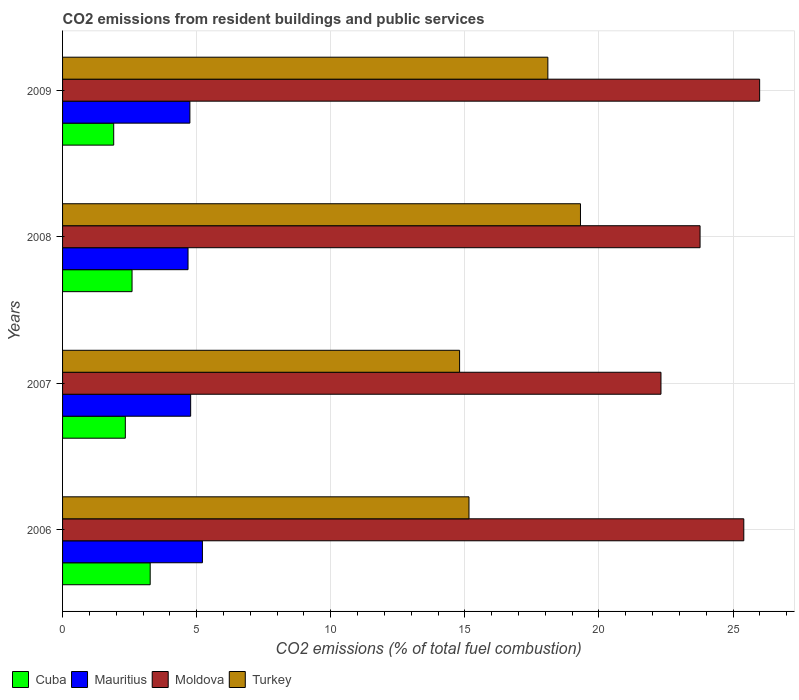How many different coloured bars are there?
Provide a succinct answer. 4. Are the number of bars per tick equal to the number of legend labels?
Your response must be concise. Yes. Are the number of bars on each tick of the Y-axis equal?
Provide a short and direct response. Yes. What is the label of the 3rd group of bars from the top?
Give a very brief answer. 2007. What is the total CO2 emitted in Turkey in 2006?
Offer a very short reply. 15.15. Across all years, what is the maximum total CO2 emitted in Moldova?
Make the answer very short. 25.99. Across all years, what is the minimum total CO2 emitted in Moldova?
Give a very brief answer. 22.31. What is the total total CO2 emitted in Turkey in the graph?
Offer a very short reply. 67.36. What is the difference between the total CO2 emitted in Mauritius in 2006 and that in 2008?
Give a very brief answer. 0.54. What is the difference between the total CO2 emitted in Cuba in 2009 and the total CO2 emitted in Turkey in 2008?
Provide a succinct answer. -17.4. What is the average total CO2 emitted in Moldova per year?
Provide a succinct answer. 24.37. In the year 2008, what is the difference between the total CO2 emitted in Moldova and total CO2 emitted in Mauritius?
Give a very brief answer. 19.09. What is the ratio of the total CO2 emitted in Cuba in 2007 to that in 2009?
Provide a succinct answer. 1.23. What is the difference between the highest and the second highest total CO2 emitted in Mauritius?
Offer a very short reply. 0.44. What is the difference between the highest and the lowest total CO2 emitted in Cuba?
Give a very brief answer. 1.36. In how many years, is the total CO2 emitted in Moldova greater than the average total CO2 emitted in Moldova taken over all years?
Offer a terse response. 2. Is the sum of the total CO2 emitted in Cuba in 2008 and 2009 greater than the maximum total CO2 emitted in Turkey across all years?
Your response must be concise. No. What does the 4th bar from the top in 2007 represents?
Make the answer very short. Cuba. How many bars are there?
Your answer should be very brief. 16. Are all the bars in the graph horizontal?
Your answer should be very brief. Yes. How many years are there in the graph?
Ensure brevity in your answer.  4. Does the graph contain any zero values?
Ensure brevity in your answer.  No. Does the graph contain grids?
Your answer should be compact. Yes. Where does the legend appear in the graph?
Your response must be concise. Bottom left. How many legend labels are there?
Make the answer very short. 4. What is the title of the graph?
Give a very brief answer. CO2 emissions from resident buildings and public services. What is the label or title of the X-axis?
Offer a very short reply. CO2 emissions (% of total fuel combustion). What is the CO2 emissions (% of total fuel combustion) in Cuba in 2006?
Offer a terse response. 3.27. What is the CO2 emissions (% of total fuel combustion) of Mauritius in 2006?
Keep it short and to the point. 5.21. What is the CO2 emissions (% of total fuel combustion) in Moldova in 2006?
Provide a succinct answer. 25.4. What is the CO2 emissions (% of total fuel combustion) of Turkey in 2006?
Keep it short and to the point. 15.15. What is the CO2 emissions (% of total fuel combustion) of Cuba in 2007?
Offer a very short reply. 2.34. What is the CO2 emissions (% of total fuel combustion) in Mauritius in 2007?
Your response must be concise. 4.78. What is the CO2 emissions (% of total fuel combustion) in Moldova in 2007?
Offer a very short reply. 22.31. What is the CO2 emissions (% of total fuel combustion) in Turkey in 2007?
Provide a short and direct response. 14.8. What is the CO2 emissions (% of total fuel combustion) of Cuba in 2008?
Give a very brief answer. 2.59. What is the CO2 emissions (% of total fuel combustion) of Mauritius in 2008?
Keep it short and to the point. 4.68. What is the CO2 emissions (% of total fuel combustion) of Moldova in 2008?
Offer a terse response. 23.77. What is the CO2 emissions (% of total fuel combustion) in Turkey in 2008?
Make the answer very short. 19.31. What is the CO2 emissions (% of total fuel combustion) of Cuba in 2009?
Offer a terse response. 1.91. What is the CO2 emissions (% of total fuel combustion) in Mauritius in 2009?
Give a very brief answer. 4.75. What is the CO2 emissions (% of total fuel combustion) of Moldova in 2009?
Offer a terse response. 25.99. What is the CO2 emissions (% of total fuel combustion) in Turkey in 2009?
Offer a terse response. 18.1. Across all years, what is the maximum CO2 emissions (% of total fuel combustion) in Cuba?
Your answer should be very brief. 3.27. Across all years, what is the maximum CO2 emissions (% of total fuel combustion) in Mauritius?
Provide a short and direct response. 5.21. Across all years, what is the maximum CO2 emissions (% of total fuel combustion) in Moldova?
Provide a short and direct response. 25.99. Across all years, what is the maximum CO2 emissions (% of total fuel combustion) in Turkey?
Ensure brevity in your answer.  19.31. Across all years, what is the minimum CO2 emissions (% of total fuel combustion) of Cuba?
Offer a terse response. 1.91. Across all years, what is the minimum CO2 emissions (% of total fuel combustion) of Mauritius?
Offer a terse response. 4.68. Across all years, what is the minimum CO2 emissions (% of total fuel combustion) in Moldova?
Your answer should be compact. 22.31. Across all years, what is the minimum CO2 emissions (% of total fuel combustion) of Turkey?
Offer a very short reply. 14.8. What is the total CO2 emissions (% of total fuel combustion) in Cuba in the graph?
Ensure brevity in your answer.  10.1. What is the total CO2 emissions (% of total fuel combustion) of Mauritius in the graph?
Keep it short and to the point. 19.42. What is the total CO2 emissions (% of total fuel combustion) of Moldova in the graph?
Ensure brevity in your answer.  97.48. What is the total CO2 emissions (% of total fuel combustion) of Turkey in the graph?
Offer a terse response. 67.36. What is the difference between the CO2 emissions (% of total fuel combustion) in Cuba in 2006 and that in 2007?
Offer a very short reply. 0.93. What is the difference between the CO2 emissions (% of total fuel combustion) of Mauritius in 2006 and that in 2007?
Give a very brief answer. 0.44. What is the difference between the CO2 emissions (% of total fuel combustion) of Moldova in 2006 and that in 2007?
Provide a short and direct response. 3.09. What is the difference between the CO2 emissions (% of total fuel combustion) in Turkey in 2006 and that in 2007?
Provide a succinct answer. 0.35. What is the difference between the CO2 emissions (% of total fuel combustion) in Cuba in 2006 and that in 2008?
Keep it short and to the point. 0.68. What is the difference between the CO2 emissions (% of total fuel combustion) of Mauritius in 2006 and that in 2008?
Provide a short and direct response. 0.54. What is the difference between the CO2 emissions (% of total fuel combustion) of Moldova in 2006 and that in 2008?
Your answer should be compact. 1.63. What is the difference between the CO2 emissions (% of total fuel combustion) of Turkey in 2006 and that in 2008?
Offer a terse response. -4.16. What is the difference between the CO2 emissions (% of total fuel combustion) in Cuba in 2006 and that in 2009?
Your response must be concise. 1.36. What is the difference between the CO2 emissions (% of total fuel combustion) in Mauritius in 2006 and that in 2009?
Ensure brevity in your answer.  0.47. What is the difference between the CO2 emissions (% of total fuel combustion) of Moldova in 2006 and that in 2009?
Provide a short and direct response. -0.59. What is the difference between the CO2 emissions (% of total fuel combustion) in Turkey in 2006 and that in 2009?
Your answer should be compact. -2.94. What is the difference between the CO2 emissions (% of total fuel combustion) of Cuba in 2007 and that in 2008?
Ensure brevity in your answer.  -0.25. What is the difference between the CO2 emissions (% of total fuel combustion) in Mauritius in 2007 and that in 2008?
Your answer should be very brief. 0.1. What is the difference between the CO2 emissions (% of total fuel combustion) of Moldova in 2007 and that in 2008?
Offer a terse response. -1.46. What is the difference between the CO2 emissions (% of total fuel combustion) of Turkey in 2007 and that in 2008?
Your answer should be very brief. -4.51. What is the difference between the CO2 emissions (% of total fuel combustion) of Cuba in 2007 and that in 2009?
Your answer should be compact. 0.43. What is the difference between the CO2 emissions (% of total fuel combustion) in Mauritius in 2007 and that in 2009?
Offer a very short reply. 0.03. What is the difference between the CO2 emissions (% of total fuel combustion) of Moldova in 2007 and that in 2009?
Offer a very short reply. -3.68. What is the difference between the CO2 emissions (% of total fuel combustion) in Turkey in 2007 and that in 2009?
Your response must be concise. -3.29. What is the difference between the CO2 emissions (% of total fuel combustion) of Cuba in 2008 and that in 2009?
Provide a short and direct response. 0.68. What is the difference between the CO2 emissions (% of total fuel combustion) of Mauritius in 2008 and that in 2009?
Keep it short and to the point. -0.07. What is the difference between the CO2 emissions (% of total fuel combustion) in Moldova in 2008 and that in 2009?
Keep it short and to the point. -2.22. What is the difference between the CO2 emissions (% of total fuel combustion) in Turkey in 2008 and that in 2009?
Your answer should be very brief. 1.22. What is the difference between the CO2 emissions (% of total fuel combustion) in Cuba in 2006 and the CO2 emissions (% of total fuel combustion) in Mauritius in 2007?
Your answer should be compact. -1.51. What is the difference between the CO2 emissions (% of total fuel combustion) in Cuba in 2006 and the CO2 emissions (% of total fuel combustion) in Moldova in 2007?
Offer a very short reply. -19.05. What is the difference between the CO2 emissions (% of total fuel combustion) of Cuba in 2006 and the CO2 emissions (% of total fuel combustion) of Turkey in 2007?
Give a very brief answer. -11.54. What is the difference between the CO2 emissions (% of total fuel combustion) in Mauritius in 2006 and the CO2 emissions (% of total fuel combustion) in Moldova in 2007?
Offer a terse response. -17.1. What is the difference between the CO2 emissions (% of total fuel combustion) in Mauritius in 2006 and the CO2 emissions (% of total fuel combustion) in Turkey in 2007?
Offer a terse response. -9.59. What is the difference between the CO2 emissions (% of total fuel combustion) of Moldova in 2006 and the CO2 emissions (% of total fuel combustion) of Turkey in 2007?
Make the answer very short. 10.6. What is the difference between the CO2 emissions (% of total fuel combustion) of Cuba in 2006 and the CO2 emissions (% of total fuel combustion) of Mauritius in 2008?
Offer a very short reply. -1.41. What is the difference between the CO2 emissions (% of total fuel combustion) in Cuba in 2006 and the CO2 emissions (% of total fuel combustion) in Moldova in 2008?
Provide a succinct answer. -20.5. What is the difference between the CO2 emissions (% of total fuel combustion) in Cuba in 2006 and the CO2 emissions (% of total fuel combustion) in Turkey in 2008?
Provide a succinct answer. -16.04. What is the difference between the CO2 emissions (% of total fuel combustion) of Mauritius in 2006 and the CO2 emissions (% of total fuel combustion) of Moldova in 2008?
Keep it short and to the point. -18.56. What is the difference between the CO2 emissions (% of total fuel combustion) in Mauritius in 2006 and the CO2 emissions (% of total fuel combustion) in Turkey in 2008?
Your answer should be compact. -14.1. What is the difference between the CO2 emissions (% of total fuel combustion) of Moldova in 2006 and the CO2 emissions (% of total fuel combustion) of Turkey in 2008?
Provide a short and direct response. 6.09. What is the difference between the CO2 emissions (% of total fuel combustion) of Cuba in 2006 and the CO2 emissions (% of total fuel combustion) of Mauritius in 2009?
Provide a short and direct response. -1.48. What is the difference between the CO2 emissions (% of total fuel combustion) in Cuba in 2006 and the CO2 emissions (% of total fuel combustion) in Moldova in 2009?
Ensure brevity in your answer.  -22.72. What is the difference between the CO2 emissions (% of total fuel combustion) of Cuba in 2006 and the CO2 emissions (% of total fuel combustion) of Turkey in 2009?
Offer a very short reply. -14.83. What is the difference between the CO2 emissions (% of total fuel combustion) of Mauritius in 2006 and the CO2 emissions (% of total fuel combustion) of Moldova in 2009?
Ensure brevity in your answer.  -20.78. What is the difference between the CO2 emissions (% of total fuel combustion) in Mauritius in 2006 and the CO2 emissions (% of total fuel combustion) in Turkey in 2009?
Your answer should be compact. -12.88. What is the difference between the CO2 emissions (% of total fuel combustion) of Moldova in 2006 and the CO2 emissions (% of total fuel combustion) of Turkey in 2009?
Your answer should be compact. 7.31. What is the difference between the CO2 emissions (% of total fuel combustion) in Cuba in 2007 and the CO2 emissions (% of total fuel combustion) in Mauritius in 2008?
Provide a succinct answer. -2.34. What is the difference between the CO2 emissions (% of total fuel combustion) of Cuba in 2007 and the CO2 emissions (% of total fuel combustion) of Moldova in 2008?
Make the answer very short. -21.43. What is the difference between the CO2 emissions (% of total fuel combustion) of Cuba in 2007 and the CO2 emissions (% of total fuel combustion) of Turkey in 2008?
Make the answer very short. -16.97. What is the difference between the CO2 emissions (% of total fuel combustion) of Mauritius in 2007 and the CO2 emissions (% of total fuel combustion) of Moldova in 2008?
Ensure brevity in your answer.  -18.99. What is the difference between the CO2 emissions (% of total fuel combustion) of Mauritius in 2007 and the CO2 emissions (% of total fuel combustion) of Turkey in 2008?
Your answer should be very brief. -14.53. What is the difference between the CO2 emissions (% of total fuel combustion) in Moldova in 2007 and the CO2 emissions (% of total fuel combustion) in Turkey in 2008?
Provide a short and direct response. 3. What is the difference between the CO2 emissions (% of total fuel combustion) in Cuba in 2007 and the CO2 emissions (% of total fuel combustion) in Mauritius in 2009?
Make the answer very short. -2.41. What is the difference between the CO2 emissions (% of total fuel combustion) in Cuba in 2007 and the CO2 emissions (% of total fuel combustion) in Moldova in 2009?
Make the answer very short. -23.65. What is the difference between the CO2 emissions (% of total fuel combustion) in Cuba in 2007 and the CO2 emissions (% of total fuel combustion) in Turkey in 2009?
Ensure brevity in your answer.  -15.75. What is the difference between the CO2 emissions (% of total fuel combustion) in Mauritius in 2007 and the CO2 emissions (% of total fuel combustion) in Moldova in 2009?
Provide a succinct answer. -21.22. What is the difference between the CO2 emissions (% of total fuel combustion) in Mauritius in 2007 and the CO2 emissions (% of total fuel combustion) in Turkey in 2009?
Provide a succinct answer. -13.32. What is the difference between the CO2 emissions (% of total fuel combustion) in Moldova in 2007 and the CO2 emissions (% of total fuel combustion) in Turkey in 2009?
Your answer should be very brief. 4.22. What is the difference between the CO2 emissions (% of total fuel combustion) in Cuba in 2008 and the CO2 emissions (% of total fuel combustion) in Mauritius in 2009?
Provide a short and direct response. -2.16. What is the difference between the CO2 emissions (% of total fuel combustion) of Cuba in 2008 and the CO2 emissions (% of total fuel combustion) of Moldova in 2009?
Offer a very short reply. -23.4. What is the difference between the CO2 emissions (% of total fuel combustion) of Cuba in 2008 and the CO2 emissions (% of total fuel combustion) of Turkey in 2009?
Make the answer very short. -15.5. What is the difference between the CO2 emissions (% of total fuel combustion) in Mauritius in 2008 and the CO2 emissions (% of total fuel combustion) in Moldova in 2009?
Make the answer very short. -21.31. What is the difference between the CO2 emissions (% of total fuel combustion) of Mauritius in 2008 and the CO2 emissions (% of total fuel combustion) of Turkey in 2009?
Make the answer very short. -13.42. What is the difference between the CO2 emissions (% of total fuel combustion) in Moldova in 2008 and the CO2 emissions (% of total fuel combustion) in Turkey in 2009?
Provide a short and direct response. 5.68. What is the average CO2 emissions (% of total fuel combustion) of Cuba per year?
Your answer should be very brief. 2.53. What is the average CO2 emissions (% of total fuel combustion) in Mauritius per year?
Your answer should be compact. 4.85. What is the average CO2 emissions (% of total fuel combustion) in Moldova per year?
Offer a terse response. 24.37. What is the average CO2 emissions (% of total fuel combustion) of Turkey per year?
Ensure brevity in your answer.  16.84. In the year 2006, what is the difference between the CO2 emissions (% of total fuel combustion) of Cuba and CO2 emissions (% of total fuel combustion) of Mauritius?
Provide a succinct answer. -1.95. In the year 2006, what is the difference between the CO2 emissions (% of total fuel combustion) in Cuba and CO2 emissions (% of total fuel combustion) in Moldova?
Offer a very short reply. -22.13. In the year 2006, what is the difference between the CO2 emissions (% of total fuel combustion) of Cuba and CO2 emissions (% of total fuel combustion) of Turkey?
Ensure brevity in your answer.  -11.89. In the year 2006, what is the difference between the CO2 emissions (% of total fuel combustion) of Mauritius and CO2 emissions (% of total fuel combustion) of Moldova?
Make the answer very short. -20.19. In the year 2006, what is the difference between the CO2 emissions (% of total fuel combustion) of Mauritius and CO2 emissions (% of total fuel combustion) of Turkey?
Keep it short and to the point. -9.94. In the year 2006, what is the difference between the CO2 emissions (% of total fuel combustion) in Moldova and CO2 emissions (% of total fuel combustion) in Turkey?
Offer a terse response. 10.25. In the year 2007, what is the difference between the CO2 emissions (% of total fuel combustion) of Cuba and CO2 emissions (% of total fuel combustion) of Mauritius?
Your response must be concise. -2.44. In the year 2007, what is the difference between the CO2 emissions (% of total fuel combustion) in Cuba and CO2 emissions (% of total fuel combustion) in Moldova?
Your response must be concise. -19.97. In the year 2007, what is the difference between the CO2 emissions (% of total fuel combustion) of Cuba and CO2 emissions (% of total fuel combustion) of Turkey?
Your answer should be very brief. -12.46. In the year 2007, what is the difference between the CO2 emissions (% of total fuel combustion) in Mauritius and CO2 emissions (% of total fuel combustion) in Moldova?
Your response must be concise. -17.54. In the year 2007, what is the difference between the CO2 emissions (% of total fuel combustion) of Mauritius and CO2 emissions (% of total fuel combustion) of Turkey?
Offer a terse response. -10.03. In the year 2007, what is the difference between the CO2 emissions (% of total fuel combustion) in Moldova and CO2 emissions (% of total fuel combustion) in Turkey?
Keep it short and to the point. 7.51. In the year 2008, what is the difference between the CO2 emissions (% of total fuel combustion) in Cuba and CO2 emissions (% of total fuel combustion) in Mauritius?
Provide a succinct answer. -2.09. In the year 2008, what is the difference between the CO2 emissions (% of total fuel combustion) of Cuba and CO2 emissions (% of total fuel combustion) of Moldova?
Offer a very short reply. -21.18. In the year 2008, what is the difference between the CO2 emissions (% of total fuel combustion) of Cuba and CO2 emissions (% of total fuel combustion) of Turkey?
Offer a terse response. -16.72. In the year 2008, what is the difference between the CO2 emissions (% of total fuel combustion) in Mauritius and CO2 emissions (% of total fuel combustion) in Moldova?
Your answer should be compact. -19.09. In the year 2008, what is the difference between the CO2 emissions (% of total fuel combustion) of Mauritius and CO2 emissions (% of total fuel combustion) of Turkey?
Make the answer very short. -14.63. In the year 2008, what is the difference between the CO2 emissions (% of total fuel combustion) of Moldova and CO2 emissions (% of total fuel combustion) of Turkey?
Ensure brevity in your answer.  4.46. In the year 2009, what is the difference between the CO2 emissions (% of total fuel combustion) of Cuba and CO2 emissions (% of total fuel combustion) of Mauritius?
Provide a succinct answer. -2.84. In the year 2009, what is the difference between the CO2 emissions (% of total fuel combustion) of Cuba and CO2 emissions (% of total fuel combustion) of Moldova?
Offer a terse response. -24.09. In the year 2009, what is the difference between the CO2 emissions (% of total fuel combustion) in Cuba and CO2 emissions (% of total fuel combustion) in Turkey?
Provide a succinct answer. -16.19. In the year 2009, what is the difference between the CO2 emissions (% of total fuel combustion) in Mauritius and CO2 emissions (% of total fuel combustion) in Moldova?
Provide a succinct answer. -21.24. In the year 2009, what is the difference between the CO2 emissions (% of total fuel combustion) of Mauritius and CO2 emissions (% of total fuel combustion) of Turkey?
Your answer should be compact. -13.35. In the year 2009, what is the difference between the CO2 emissions (% of total fuel combustion) in Moldova and CO2 emissions (% of total fuel combustion) in Turkey?
Your response must be concise. 7.9. What is the ratio of the CO2 emissions (% of total fuel combustion) of Cuba in 2006 to that in 2007?
Your answer should be very brief. 1.4. What is the ratio of the CO2 emissions (% of total fuel combustion) in Mauritius in 2006 to that in 2007?
Give a very brief answer. 1.09. What is the ratio of the CO2 emissions (% of total fuel combustion) in Moldova in 2006 to that in 2007?
Give a very brief answer. 1.14. What is the ratio of the CO2 emissions (% of total fuel combustion) of Turkey in 2006 to that in 2007?
Offer a very short reply. 1.02. What is the ratio of the CO2 emissions (% of total fuel combustion) of Cuba in 2006 to that in 2008?
Make the answer very short. 1.26. What is the ratio of the CO2 emissions (% of total fuel combustion) in Mauritius in 2006 to that in 2008?
Give a very brief answer. 1.11. What is the ratio of the CO2 emissions (% of total fuel combustion) in Moldova in 2006 to that in 2008?
Your answer should be very brief. 1.07. What is the ratio of the CO2 emissions (% of total fuel combustion) in Turkey in 2006 to that in 2008?
Provide a succinct answer. 0.78. What is the ratio of the CO2 emissions (% of total fuel combustion) of Cuba in 2006 to that in 2009?
Offer a very short reply. 1.71. What is the ratio of the CO2 emissions (% of total fuel combustion) in Mauritius in 2006 to that in 2009?
Your answer should be very brief. 1.1. What is the ratio of the CO2 emissions (% of total fuel combustion) in Moldova in 2006 to that in 2009?
Provide a succinct answer. 0.98. What is the ratio of the CO2 emissions (% of total fuel combustion) of Turkey in 2006 to that in 2009?
Offer a very short reply. 0.84. What is the ratio of the CO2 emissions (% of total fuel combustion) of Cuba in 2007 to that in 2008?
Your response must be concise. 0.9. What is the ratio of the CO2 emissions (% of total fuel combustion) in Mauritius in 2007 to that in 2008?
Give a very brief answer. 1.02. What is the ratio of the CO2 emissions (% of total fuel combustion) in Moldova in 2007 to that in 2008?
Give a very brief answer. 0.94. What is the ratio of the CO2 emissions (% of total fuel combustion) of Turkey in 2007 to that in 2008?
Your answer should be compact. 0.77. What is the ratio of the CO2 emissions (% of total fuel combustion) of Cuba in 2007 to that in 2009?
Give a very brief answer. 1.23. What is the ratio of the CO2 emissions (% of total fuel combustion) of Moldova in 2007 to that in 2009?
Ensure brevity in your answer.  0.86. What is the ratio of the CO2 emissions (% of total fuel combustion) of Turkey in 2007 to that in 2009?
Ensure brevity in your answer.  0.82. What is the ratio of the CO2 emissions (% of total fuel combustion) in Cuba in 2008 to that in 2009?
Offer a terse response. 1.36. What is the ratio of the CO2 emissions (% of total fuel combustion) of Mauritius in 2008 to that in 2009?
Make the answer very short. 0.99. What is the ratio of the CO2 emissions (% of total fuel combustion) of Moldova in 2008 to that in 2009?
Keep it short and to the point. 0.91. What is the ratio of the CO2 emissions (% of total fuel combustion) in Turkey in 2008 to that in 2009?
Ensure brevity in your answer.  1.07. What is the difference between the highest and the second highest CO2 emissions (% of total fuel combustion) of Cuba?
Make the answer very short. 0.68. What is the difference between the highest and the second highest CO2 emissions (% of total fuel combustion) of Mauritius?
Offer a terse response. 0.44. What is the difference between the highest and the second highest CO2 emissions (% of total fuel combustion) of Moldova?
Your answer should be compact. 0.59. What is the difference between the highest and the second highest CO2 emissions (% of total fuel combustion) in Turkey?
Your answer should be very brief. 1.22. What is the difference between the highest and the lowest CO2 emissions (% of total fuel combustion) of Cuba?
Offer a terse response. 1.36. What is the difference between the highest and the lowest CO2 emissions (% of total fuel combustion) of Mauritius?
Ensure brevity in your answer.  0.54. What is the difference between the highest and the lowest CO2 emissions (% of total fuel combustion) in Moldova?
Give a very brief answer. 3.68. What is the difference between the highest and the lowest CO2 emissions (% of total fuel combustion) of Turkey?
Provide a short and direct response. 4.51. 